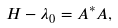<formula> <loc_0><loc_0><loc_500><loc_500>H - \lambda _ { 0 } = A ^ { * } A ,</formula> 